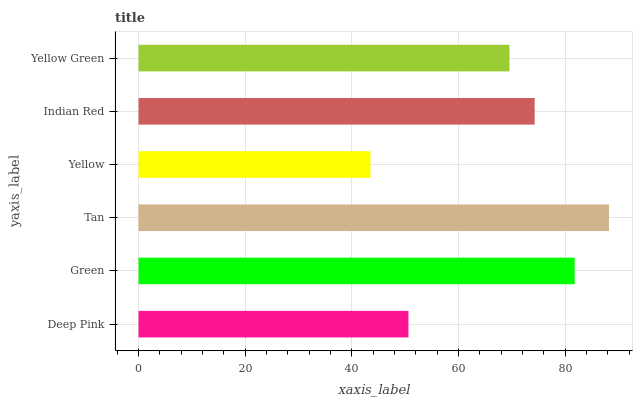Is Yellow the minimum?
Answer yes or no. Yes. Is Tan the maximum?
Answer yes or no. Yes. Is Green the minimum?
Answer yes or no. No. Is Green the maximum?
Answer yes or no. No. Is Green greater than Deep Pink?
Answer yes or no. Yes. Is Deep Pink less than Green?
Answer yes or no. Yes. Is Deep Pink greater than Green?
Answer yes or no. No. Is Green less than Deep Pink?
Answer yes or no. No. Is Indian Red the high median?
Answer yes or no. Yes. Is Yellow Green the low median?
Answer yes or no. Yes. Is Yellow Green the high median?
Answer yes or no. No. Is Green the low median?
Answer yes or no. No. 